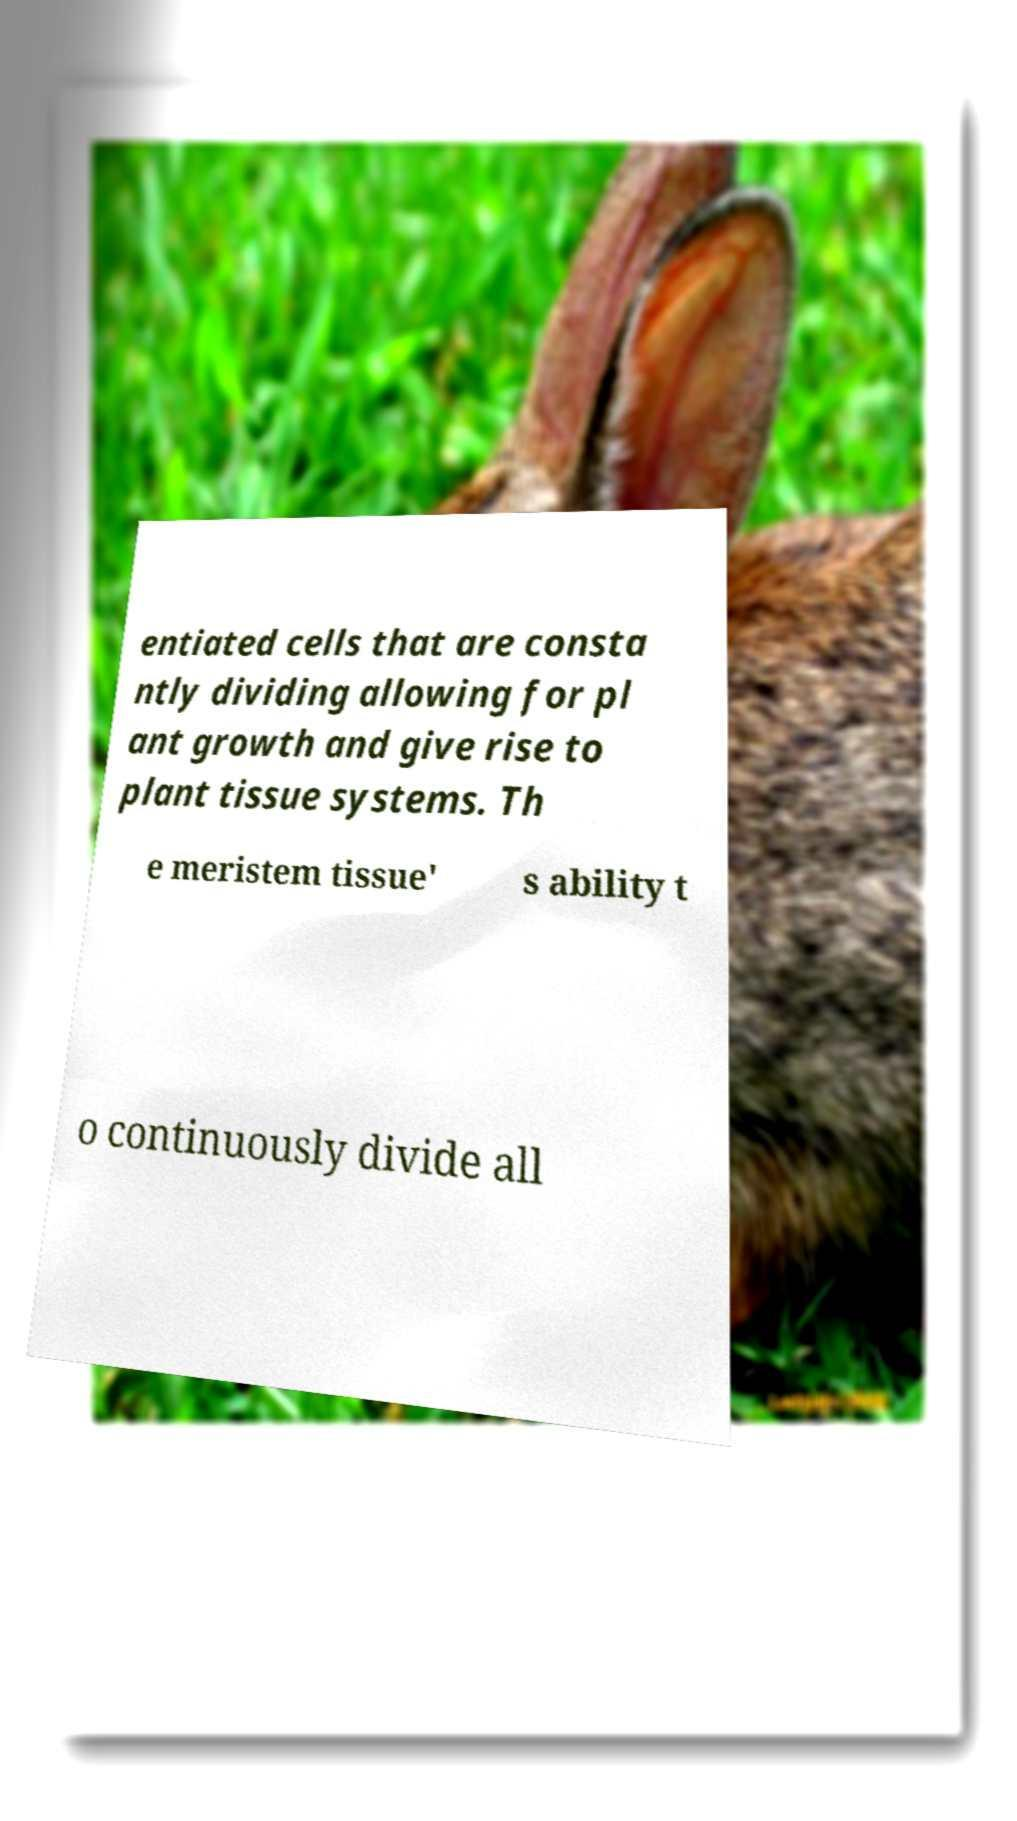Can you read and provide the text displayed in the image?This photo seems to have some interesting text. Can you extract and type it out for me? entiated cells that are consta ntly dividing allowing for pl ant growth and give rise to plant tissue systems. Th e meristem tissue' s ability t o continuously divide all 